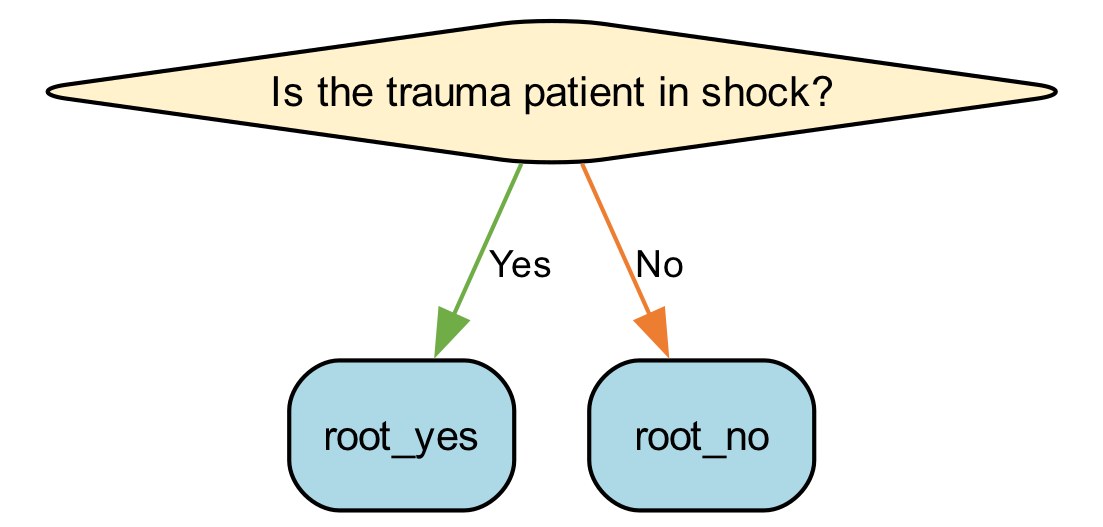What is the first question in the decision tree? The first question in the decision tree is found in Step1 under MedicationSelection. It asks, "Is the trauma patient in shock?"
Answer: Is the trauma patient in shock? How many medications are listed in the decision tree? By analyzing the entire decision tree, the nodes that contain medication names are identified. There are a total of five medications provided at the endpoints: Normal Saline, Dopamine, Norepinephrine, Fentanyl, Ceftriaxone, and Ibuprofen.
Answer: Five medications What medication is suggested for hypovolemic shock? The medication suggested for hypovolemic shock is found in the "Yes" branch of Step2 under the question about hypovolemic shock. It is clearly labeled: Normal Saline.
Answer: Normal Saline If a patient is not in shock but has severe pain, what medication is recommended? Following the flow, if the patient is not in shock (Step4, No), and they are experiencing severe pain (Step4, Yes), the recommended medication is Fentanyl, as indicated in that path of the tree.
Answer: Fentanyl What are the side effects of Norepinephrine? To find the side effects of Norepinephrine, we look at the end node after the corresponding medication name. It states that the side effects include "Peripheral ischemia, hypertension."
Answer: Peripheral ischemia, hypertension What is the effectiveness of Ceftriaxone? The effectiveness is noted in the node for Ceftriaxone, specifically explaining what it does in the context of treatment. It is mentioned as a "Broad-spectrum antibiotic."
Answer: Broad-spectrum antibiotic What is the effect on cardiac output from Dopamine? To answer this, we locate the node for Dopamine in Step3. It states that the effectiveness is described as "Increases cardiac output."
Answer: Increases cardiac output If the patient is experiencing severe pain and is also in shock, which medication takes priority? Evaluating the structure of the diagram, if a patient is in shock, Step1 allows us to move forward for a treatment decision. The presence of shock takes priority over pain, leading to medications like Normal Saline, Dopamine, or Norepinephrine, depending on shock type.
Answer: Shock medications take priority 